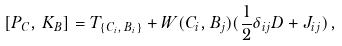Convert formula to latex. <formula><loc_0><loc_0><loc_500><loc_500>[ P _ { C } , \, K _ { B } ] = T _ { \{ C _ { i } , \, B _ { i } \} } + W ( C _ { i } , B _ { j } ) ( \frac { 1 } { 2 } \delta _ { i j } D + J _ { i j } ) \, ,</formula> 